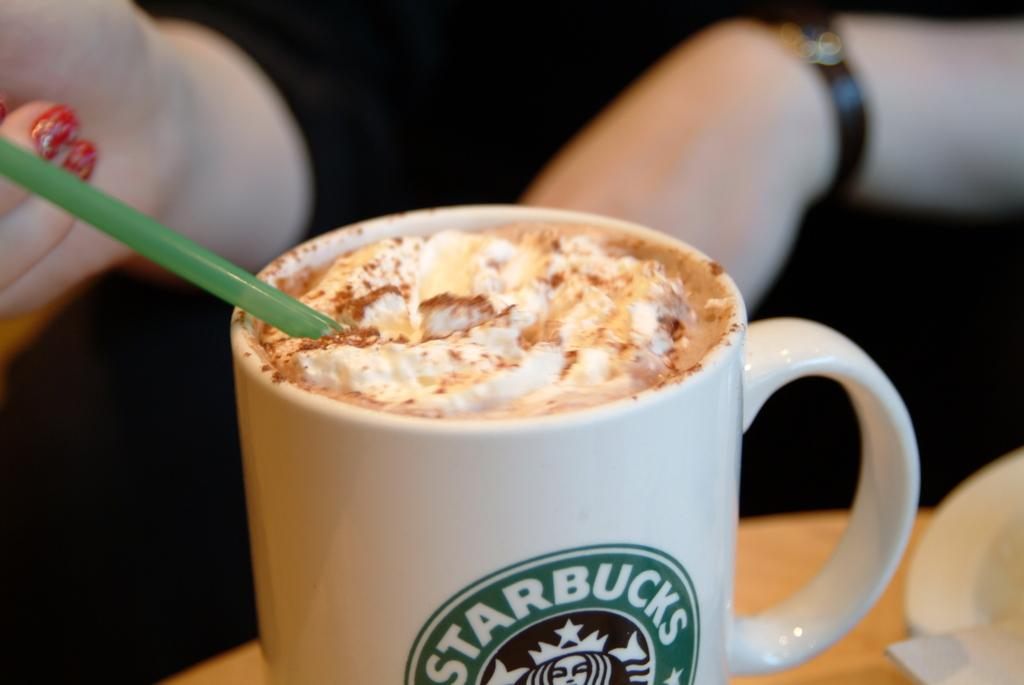What piece of furniture is present in the image? There is a table in the image. What object is placed on the table? There is a mug on the table. What is inside the mug? There is liquid in the mug. Who is present in the image? A woman is sitting near the table. How is the woman interacting with the mug? The woman has placed a straw in the mug. What type of drain is visible in the image? There is no drain present in the image. How does the woman's tongue interact with the liquid in the mug? The woman's tongue is not visible in the image, so it is not possible to determine how it interacts with the liquid in the mug. 